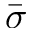<formula> <loc_0><loc_0><loc_500><loc_500>\ B a r { \sigma }</formula> 